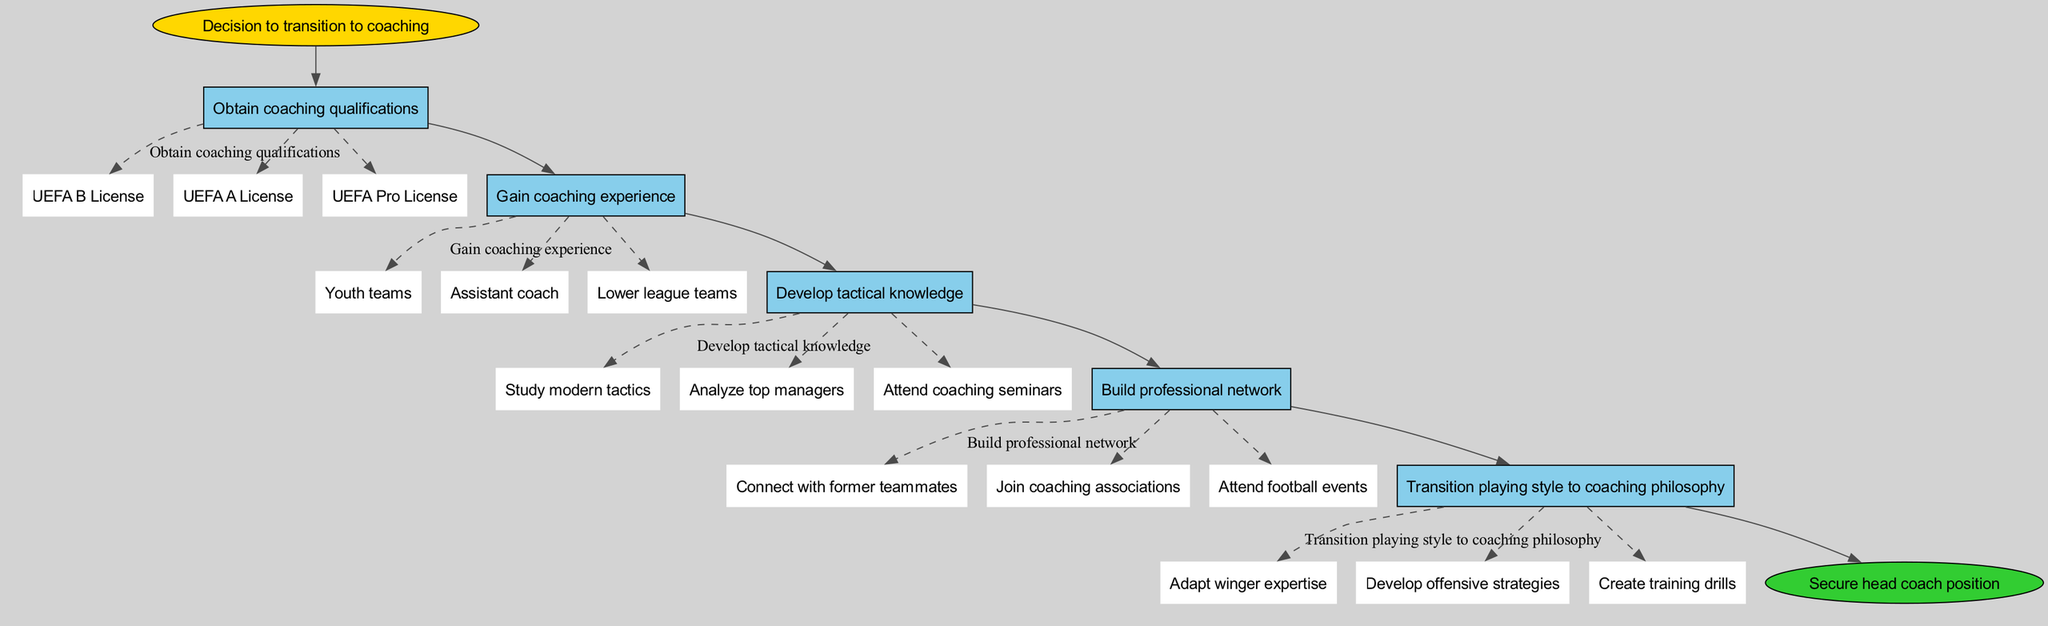What is the starting point of the transition process? The diagram indicates that the starting point of the transition process is labeled as "Decision to transition to coaching".
Answer: Decision to transition to coaching How many main steps are in the transition process? By counting the steps listed in the diagram, there are a total of five main steps, each leading to the next in the flow.
Answer: 5 What does the final step lead to? The diagram shows that the final step transitions to a "Secure head coach position", indicating the ultimate goal of the process.
Answer: Secure head coach position What are the substeps under 'Gain coaching experience'? The substeps listed under this step are "Youth teams", "Assistant coach", and "Lower league teams", which detail different paths to gain experience.
Answer: Youth teams, Assistant coach, Lower league teams Which step involves studying tactics? The step labeled "Develop tactical knowledge" involves studying tactics, which is specified as a necessary part of coaching development in the diagram.
Answer: Develop tactical knowledge How do you transition your playing style to coaching? The diagram suggests that transitioning your playing style to coaching philosophy involves three substeps: "Adapt winger expertise", "Develop offensive strategies", and "Create training drills".
Answer: Adapt winger expertise, Develop offensive strategies, Create training drills What is the relationship between 'Obtain coaching qualifications' and 'Gain coaching experience'? The diagram shows that "Obtain coaching qualifications" is the first main step that flows into "Gain coaching experience", indicating that qualifications are obtained before gaining experience.
Answer: Sequential Flow Which step includes attending football events? The step titled "Build professional network" includes attending football events as one of its substeps, which helps in connecting with others in the coaching field.
Answer: Build professional network 